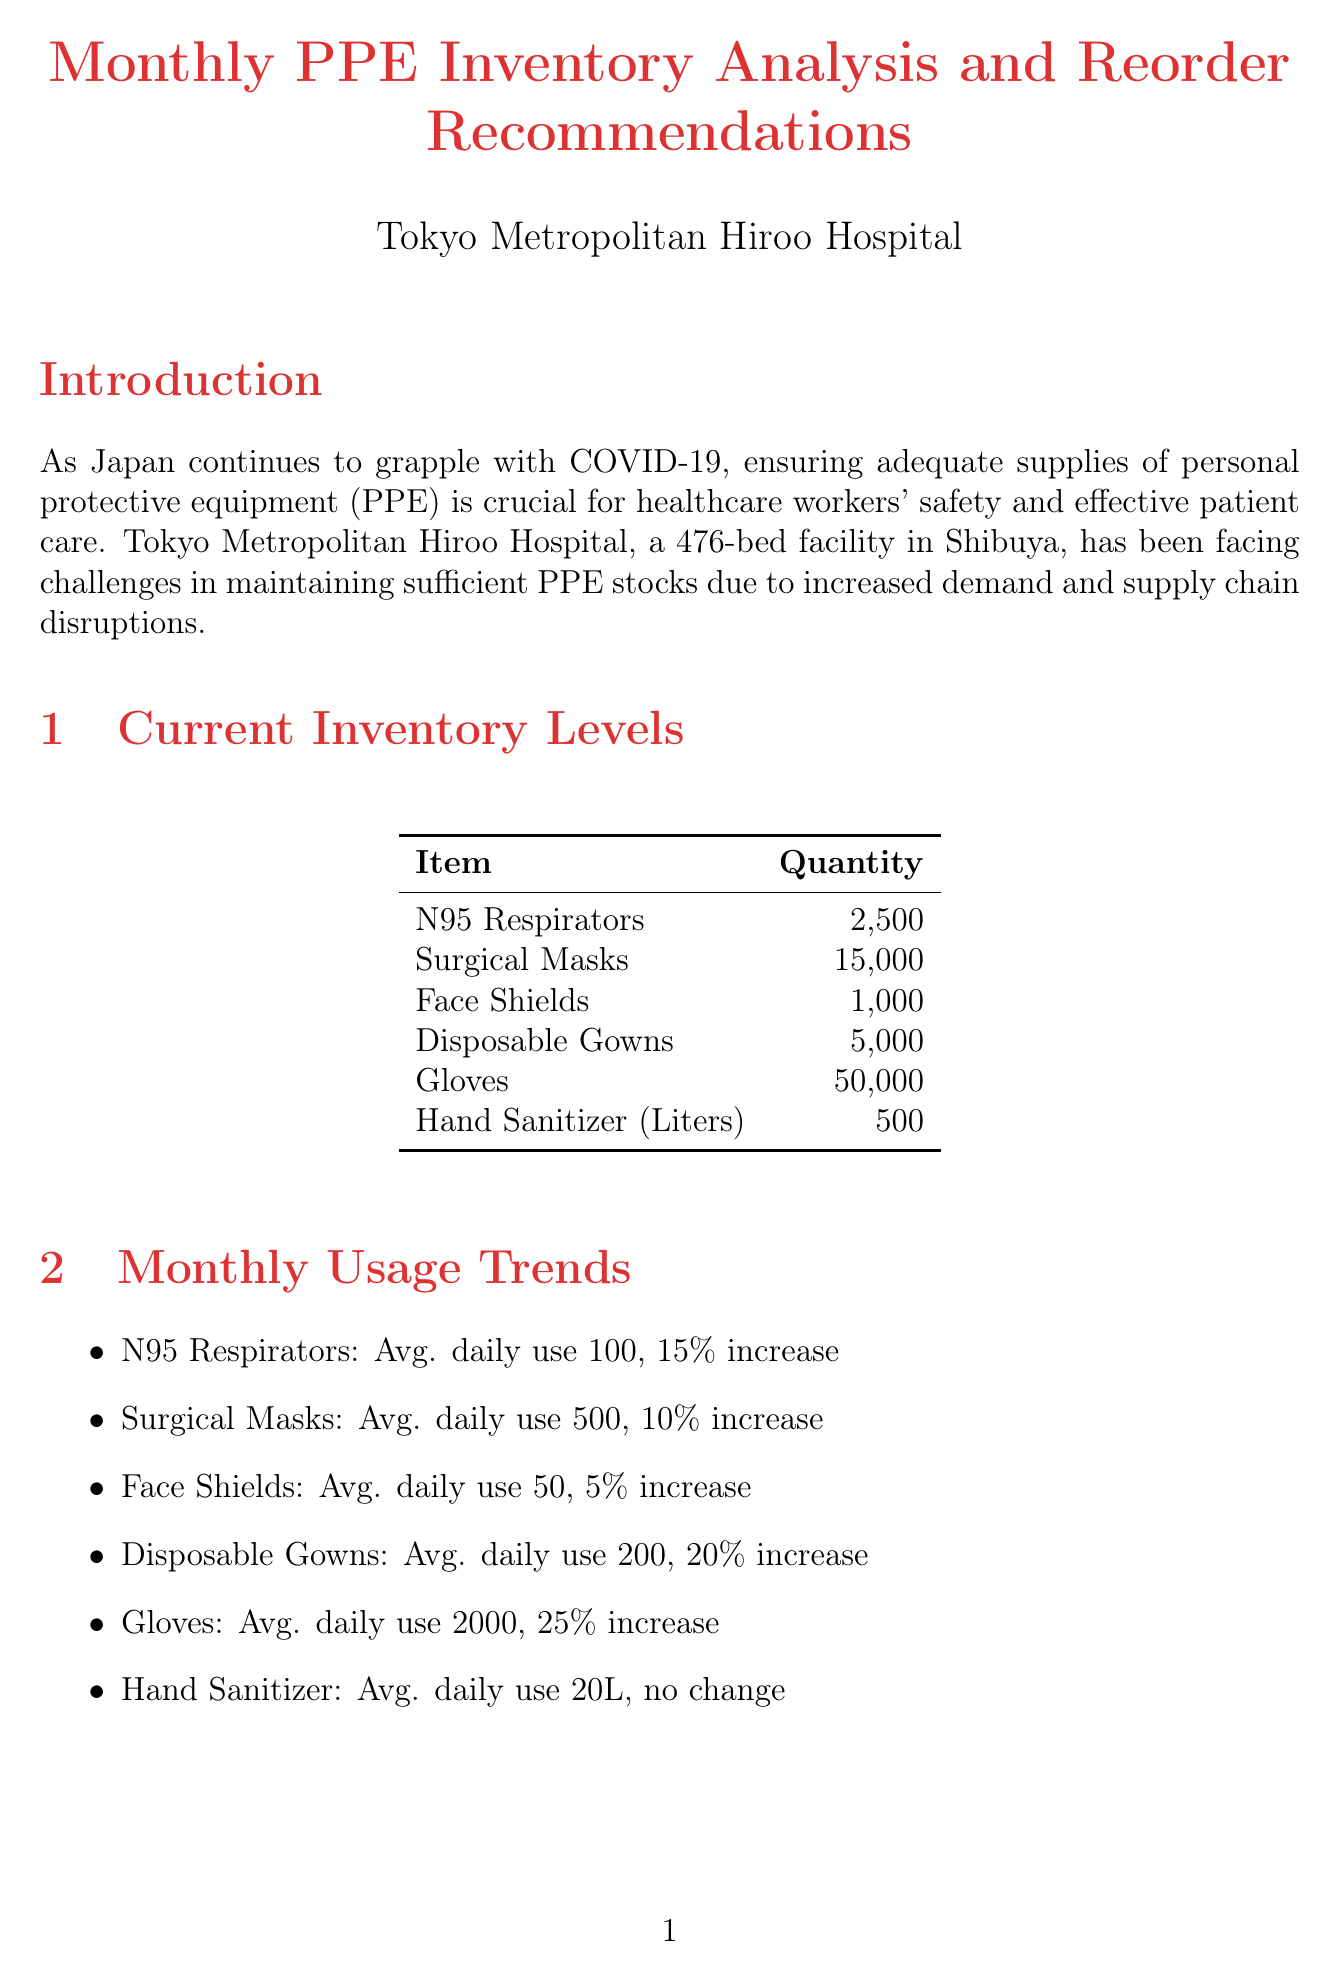what is the current inventory level of N95 respirators? The document states that the current inventory level of N95 respirators is 2500.
Answer: 2500 what is the average daily usage of surgical masks? According to the monthly usage trends, the average daily usage of surgical masks is 500.
Answer: 500 what is the urgency level for ordering disposable gowns? The reorder recommendations indicate that the urgency level for ordering disposable gowns is High.
Answer: High who is the supplier for hand sanitizer? The reorder recommendations specify Saraya Co., Ltd. as the supplier for hand sanitizer.
Answer: Saraya Co., Ltd what is the percent change in total monthly PPE expenses from the previous month? The document shows that total monthly PPE expenses have increased by 18% from the previous month.
Answer: 18% how many gloves are recommended to reorder? The reorder recommendations state that 60000 gloves should be reordered.
Answer: 60000 what are the delivery times for domestic suppliers? The document mentions that the delivery time for domestic suppliers is 3-5 business days.
Answer: 3-5 business days which PPE item has the highest average daily usage increase percentage? The monthly usage trends indicate that gloves have the highest average daily usage increase of 25%.
Answer: 25% what is the total monthly PPE expense reported? The document notes that the total monthly PPE expenses are ¥15,000,000.
Answer: ¥15,000,000 